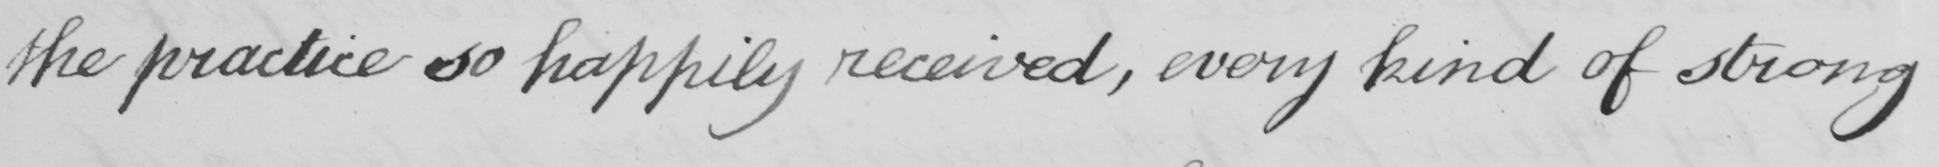Can you tell me what this handwritten text says? the practice so happily received, every kind of strong 